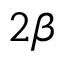<formula> <loc_0><loc_0><loc_500><loc_500>2 \beta</formula> 